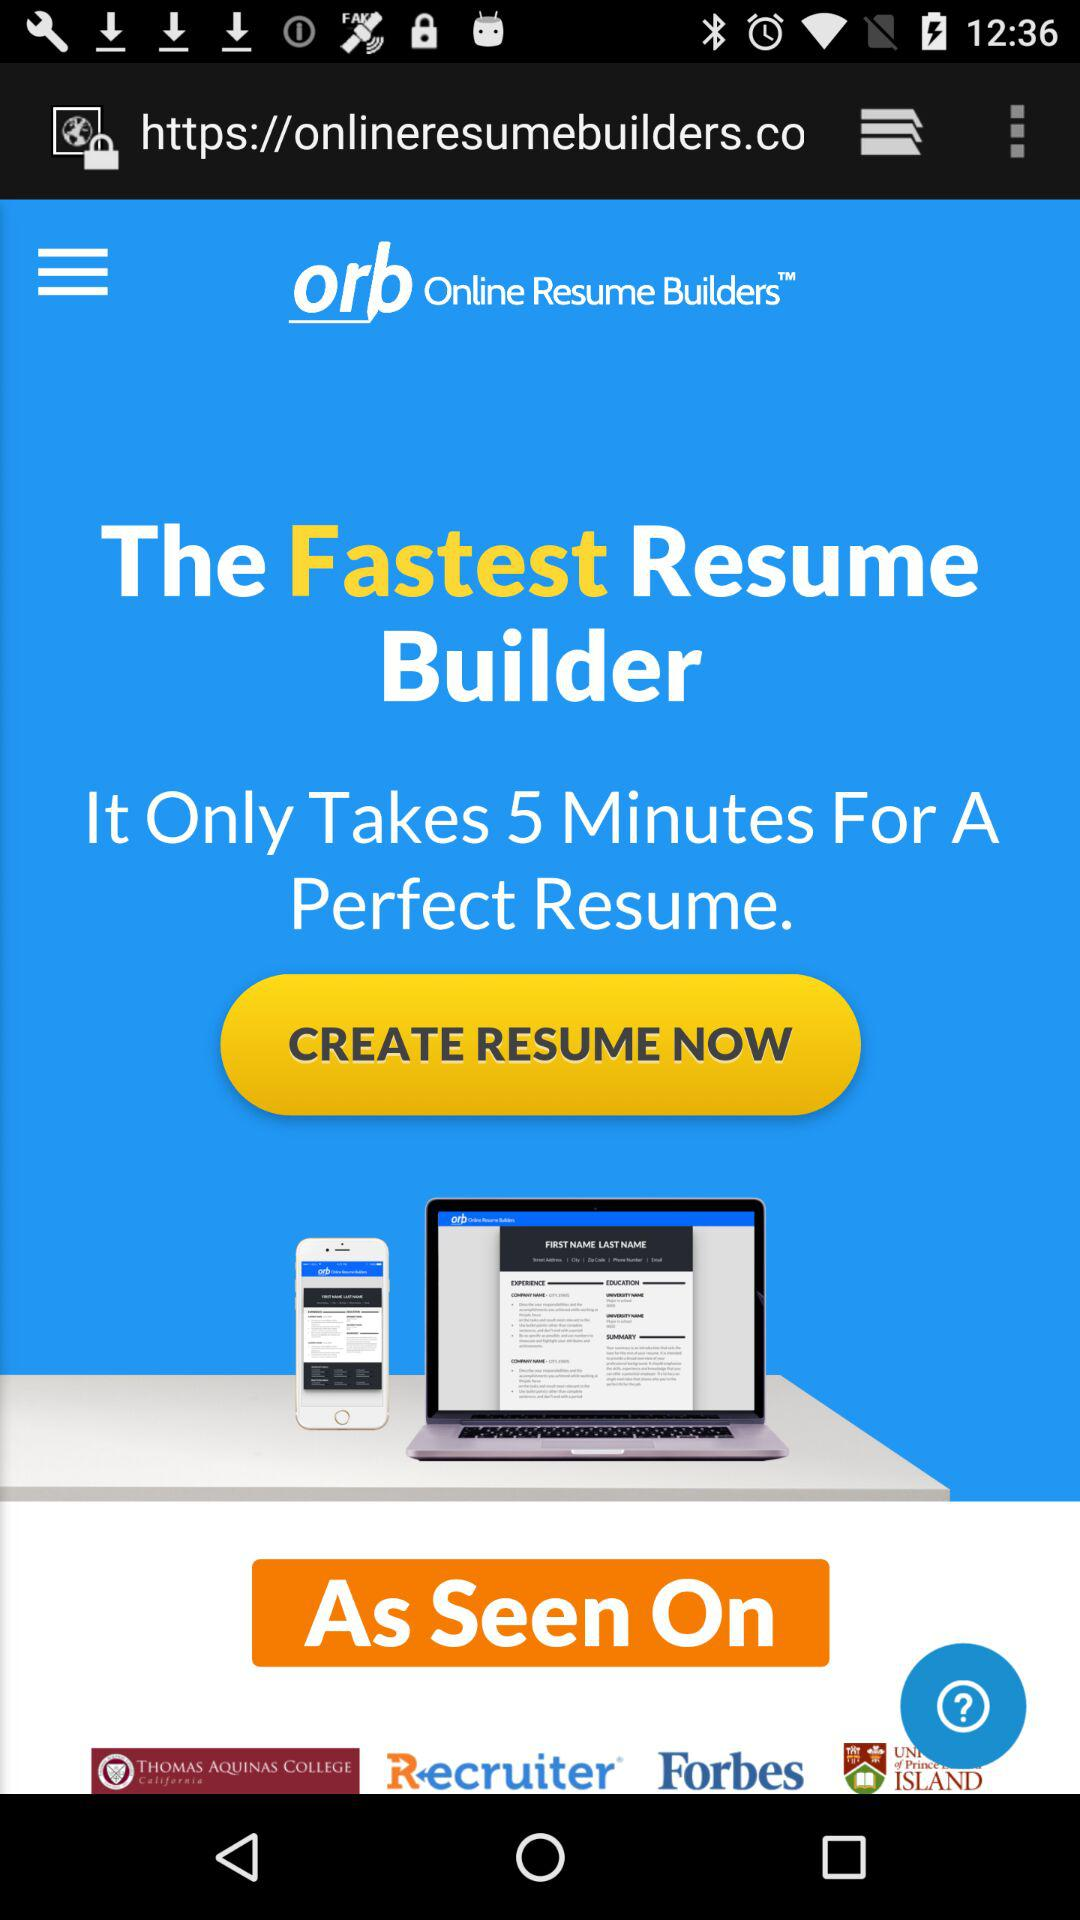What is the fastest resume builder? The fastest resume builder is "orb Online Resume Builders". 